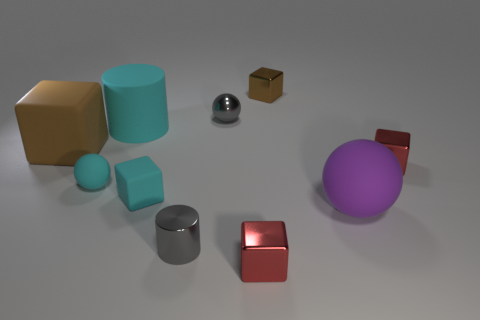The metal thing that is both left of the brown shiny object and behind the matte cylinder is what color?
Ensure brevity in your answer.  Gray. What shape is the cyan rubber object that is the same size as the purple ball?
Keep it short and to the point. Cylinder. Is there another large matte thing of the same shape as the purple rubber thing?
Offer a very short reply. No. Is the material of the gray cylinder the same as the cylinder behind the purple rubber object?
Keep it short and to the point. No. There is a matte block to the left of the small ball that is left of the ball behind the cyan rubber ball; what is its color?
Keep it short and to the point. Brown. There is a cylinder that is the same size as the metal ball; what is its material?
Offer a terse response. Metal. How many purple objects are the same material as the purple ball?
Ensure brevity in your answer.  0. There is a cyan thing on the right side of the large cylinder; does it have the same size as the red block that is behind the gray cylinder?
Ensure brevity in your answer.  Yes. There is a cube that is in front of the small cylinder; what is its color?
Offer a very short reply. Red. There is a cylinder that is the same color as the metallic ball; what is it made of?
Your answer should be compact. Metal. 